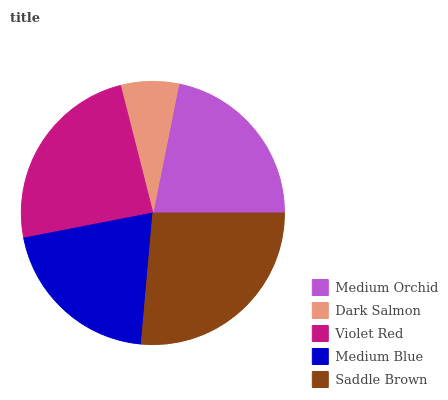Is Dark Salmon the minimum?
Answer yes or no. Yes. Is Saddle Brown the maximum?
Answer yes or no. Yes. Is Violet Red the minimum?
Answer yes or no. No. Is Violet Red the maximum?
Answer yes or no. No. Is Violet Red greater than Dark Salmon?
Answer yes or no. Yes. Is Dark Salmon less than Violet Red?
Answer yes or no. Yes. Is Dark Salmon greater than Violet Red?
Answer yes or no. No. Is Violet Red less than Dark Salmon?
Answer yes or no. No. Is Medium Orchid the high median?
Answer yes or no. Yes. Is Medium Orchid the low median?
Answer yes or no. Yes. Is Violet Red the high median?
Answer yes or no. No. Is Violet Red the low median?
Answer yes or no. No. 